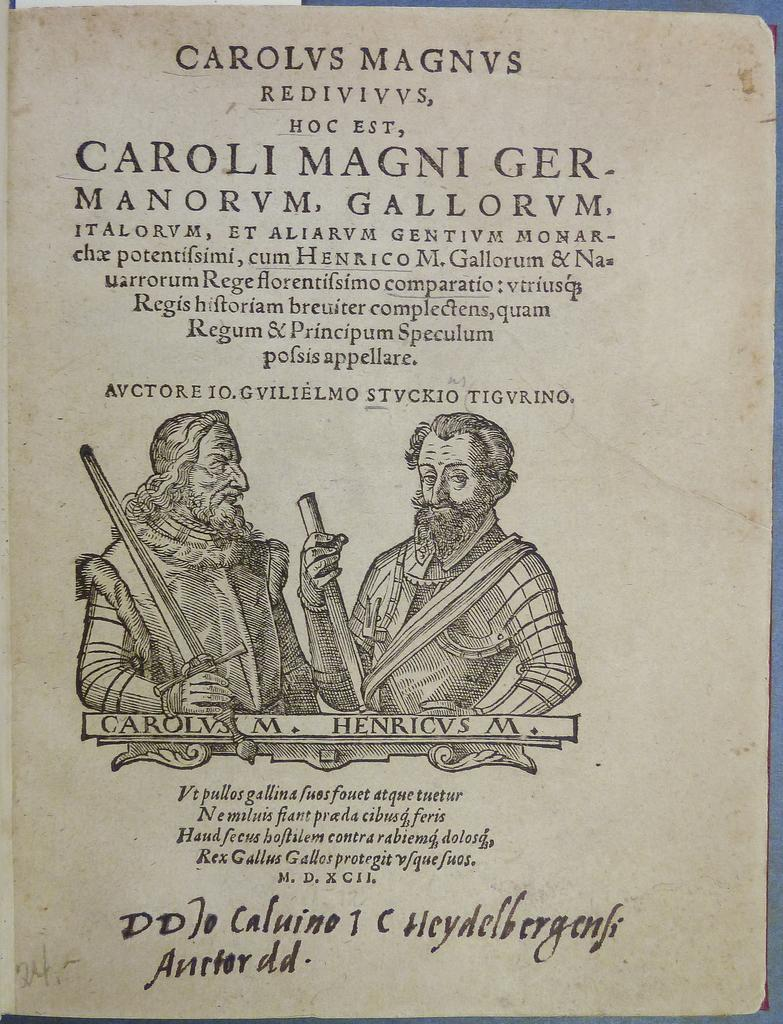What is the main subject of the image? The image contains the first page of a book. Can you describe any specific details about the page? Unfortunately, the provided facts do not include any specific details about the page. How many icicles are hanging from the breakfast in the image? There is no breakfast or icicles present in the image; it contains the first page of a book. 